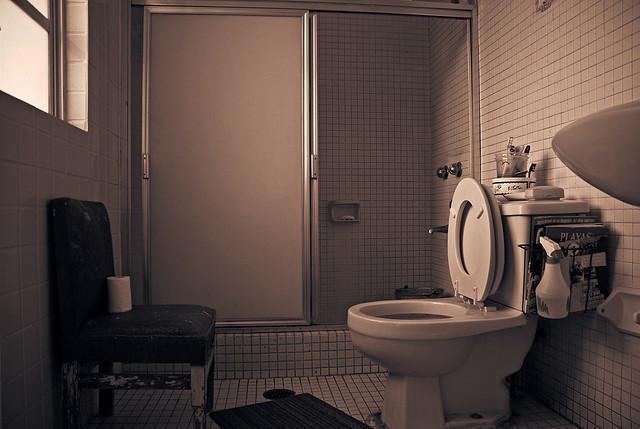How many types of tile is shown?
Give a very brief answer. 2. How many black containers are on top of the toilet?
Give a very brief answer. 0. 